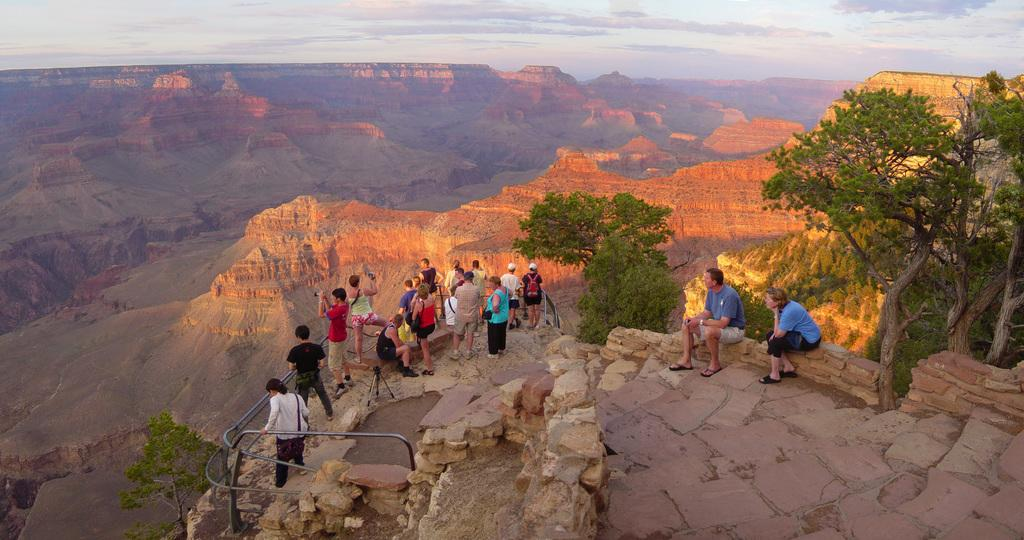What are the people in the image doing on the mountain? Some people are standing, and some are sitting on the mountain in the image. What can be seen in the background of the image? There are mountains, trees, and the sky visible in the background of the image. How many sheep are visible in the image? There are no sheep present in the image. What type of attention is the person in the image giving to the bath? There is no person in the image giving attention to a bath, as the image features people on a mountain with no reference to a bath. 